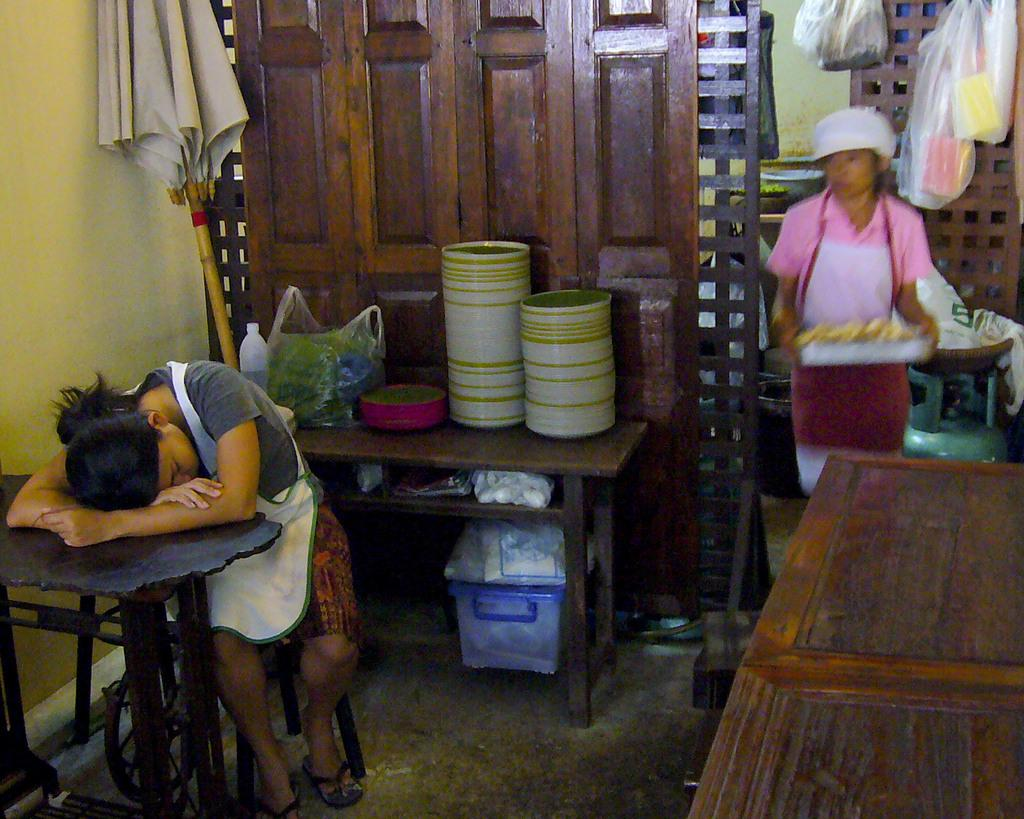What is the position of the woman in the image? There is a woman seated and a woman standing in the image. What is the standing woman holding? The standing woman is holding a tray. What objects can be seen on the tray? The provided facts do not mention the contents of the tray. Are there any plates visible in the image? Yes, there are plates visible in the image. What type of linen is being used to cover the plates in the image? There is no mention of linen or any type of covering for the plates in the provided facts. 